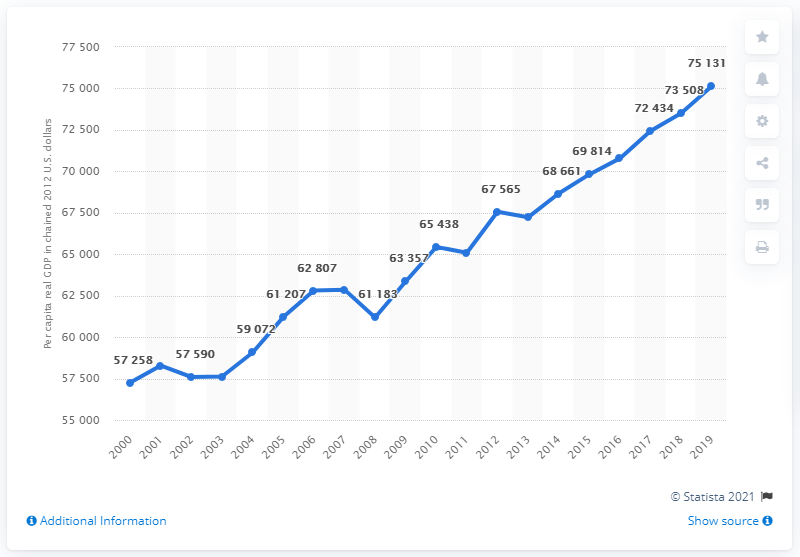Give some essential details in this illustration. In the year 2012, the per capita real GDP of New York stood at 75,131, adjusted for inflation using a chain price index. 